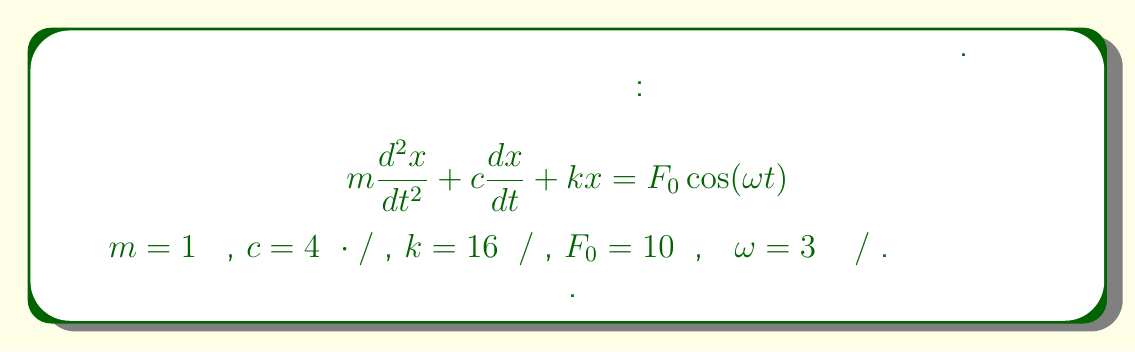Could you help me with this problem? Для решения этой задачи выполним следующие шаги:

1) Общее решение для установившихся колебаний имеет вид:

   $$x(t) = A\cos(\omega t - \phi)$$

   где $A$ - амплитуда колебаний, а $\phi$ - сдвиг фазы.

2) Амплитуда $A$ определяется формулой:

   $$A = \frac{F_0}{\sqrt{(k-m\omega^2)^2 + (c\omega)^2}}$$

3) Подставим известные значения:
   
   $m = 1$ кг
   $c = 4$ Н⋅с/м
   $k = 16$ Н/м
   $F_0 = 10$ Н
   $\omega = 3$ рад/с

4) Вычислим:

   $$A = \frac{10}{\sqrt{(16-1\cdot3^2)^2 + (4\cdot3)^2}}$$

5) Упростим:

   $$A = \frac{10}{\sqrt{(16-9)^2 + 12^2}} = \frac{10}{\sqrt{7^2 + 12^2}}$$

6) Вычислим:

   $$A = \frac{10}{\sqrt{49 + 144}} = \frac{10}{\sqrt{193}} \approx 0.72$$

Таким образом, амплитуда установившихся колебаний системы приблизительно равна 0.72 метра.
Answer: $A \approx 0.72$ м 